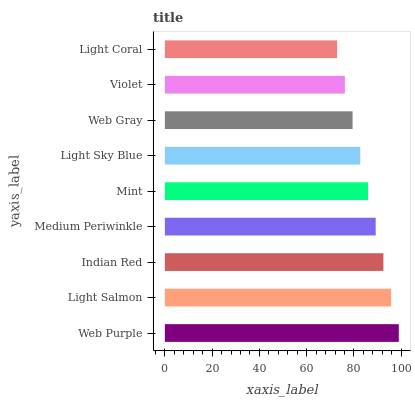Is Light Coral the minimum?
Answer yes or no. Yes. Is Web Purple the maximum?
Answer yes or no. Yes. Is Light Salmon the minimum?
Answer yes or no. No. Is Light Salmon the maximum?
Answer yes or no. No. Is Web Purple greater than Light Salmon?
Answer yes or no. Yes. Is Light Salmon less than Web Purple?
Answer yes or no. Yes. Is Light Salmon greater than Web Purple?
Answer yes or no. No. Is Web Purple less than Light Salmon?
Answer yes or no. No. Is Mint the high median?
Answer yes or no. Yes. Is Mint the low median?
Answer yes or no. Yes. Is Medium Periwinkle the high median?
Answer yes or no. No. Is Web Purple the low median?
Answer yes or no. No. 